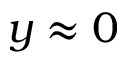Convert formula to latex. <formula><loc_0><loc_0><loc_500><loc_500>y \approx 0</formula> 